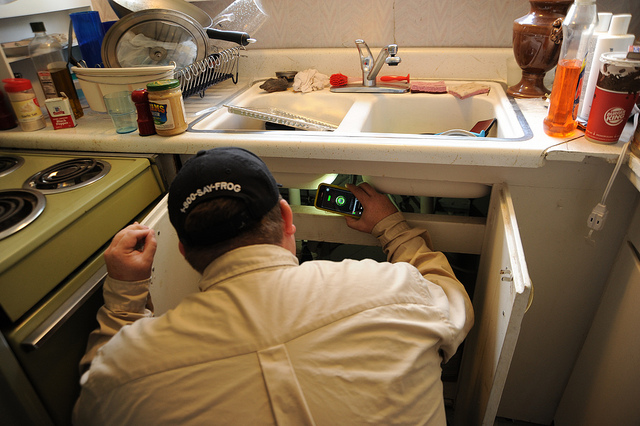Please extract the text content from this image. 1-500-SAY-FROC 